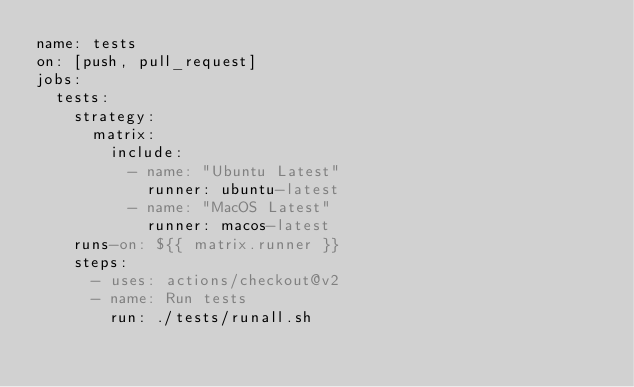Convert code to text. <code><loc_0><loc_0><loc_500><loc_500><_YAML_>name: tests
on: [push, pull_request]
jobs:
  tests:
    strategy:
      matrix:
        include:
          - name: "Ubuntu Latest"
            runner: ubuntu-latest
          - name: "MacOS Latest"
            runner: macos-latest
    runs-on: ${{ matrix.runner }}
    steps:
      - uses: actions/checkout@v2
      - name: Run tests
        run: ./tests/runall.sh
</code> 